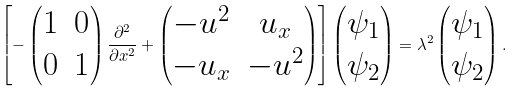Convert formula to latex. <formula><loc_0><loc_0><loc_500><loc_500>\left [ - \begin{pmatrix} 1 & 0 \\ 0 & 1 \end{pmatrix} \frac { \partial ^ { 2 } } { \partial x ^ { 2 } } + \begin{pmatrix} - u ^ { 2 } & u _ { x } \\ - u _ { x } & - u ^ { 2 } \end{pmatrix} \right ] \begin{pmatrix} \psi _ { 1 } \\ \psi _ { 2 } \end{pmatrix} = \lambda ^ { 2 } \begin{pmatrix} \psi _ { 1 } \\ \psi _ { 2 } \end{pmatrix} .</formula> 